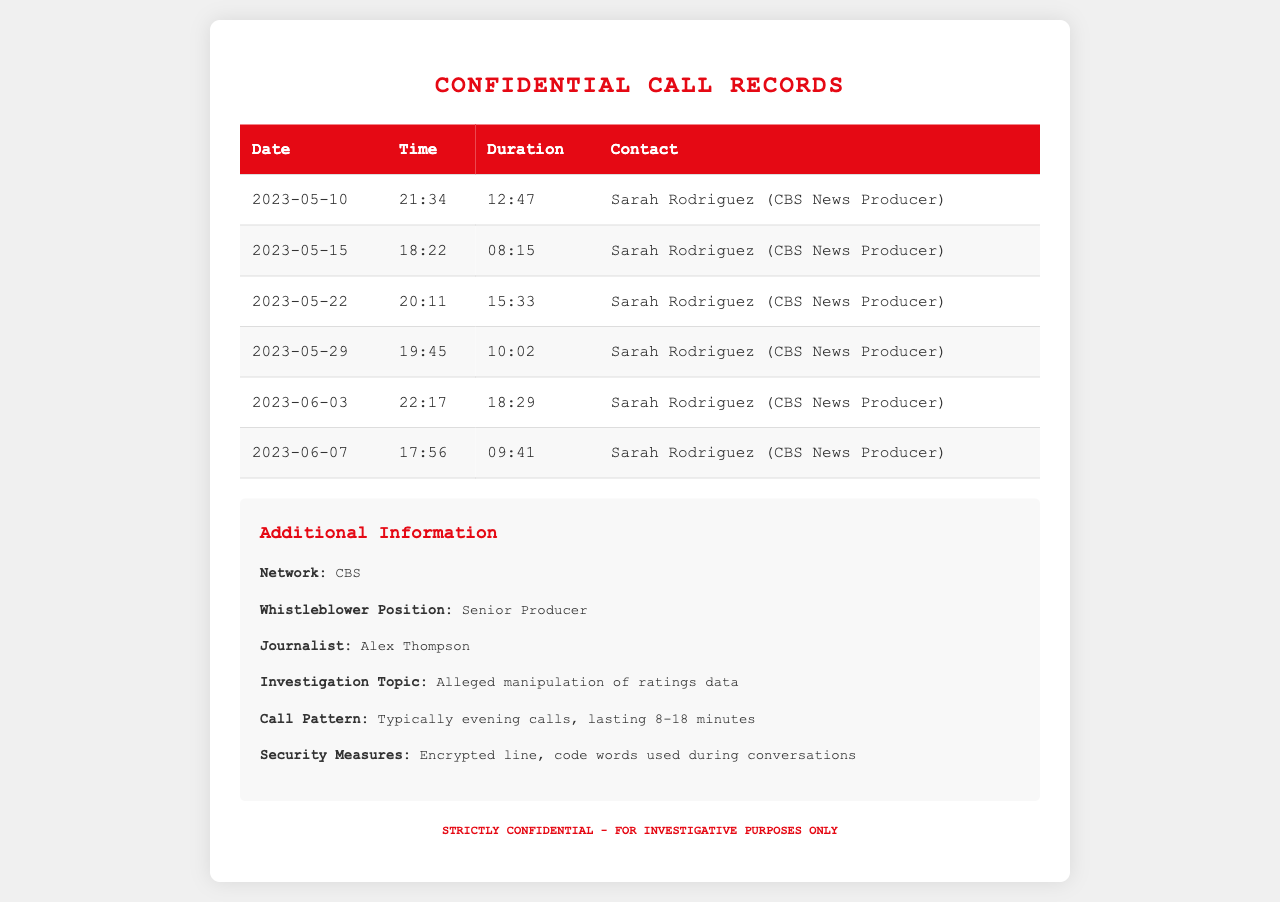what is the first call date recorded? The first call entry in the records is dated May 10, 2023.
Answer: May 10, 2023 who is the whistleblower? The document lists the whistleblower's position as Senior Producer, indicating their role at the network.
Answer: Sarah Rodriguez how long did the longest call last? The longest call duration recorded is 18 minutes and 29 seconds.
Answer: 18:29 what is the average duration of the calls listed? The average duration can be derived from the listed call durations, which average to around 12 minutes and 5 seconds.
Answer: 12:05 which network is mentioned in these records? The document explicitly states the network that the whistleblower is associated with.
Answer: CBS how many calls occurred in June 2023? Based on the records, there are two calls listed in June 2023.
Answer: 2 what is the main investigation topic mentioned? The document specifies the investigation topic that is being pursued, which relates to a significant issue within the network.
Answer: Alleged manipulation of ratings data what is the typical call pattern observed in the records? The document describes the general timing and length of calls that typically occur based on the data provided.
Answer: Typically evening calls, lasting 8-18 minutes how many call records are there in total? The total number of call records can be counted directly from the entries in the table.
Answer: 6 